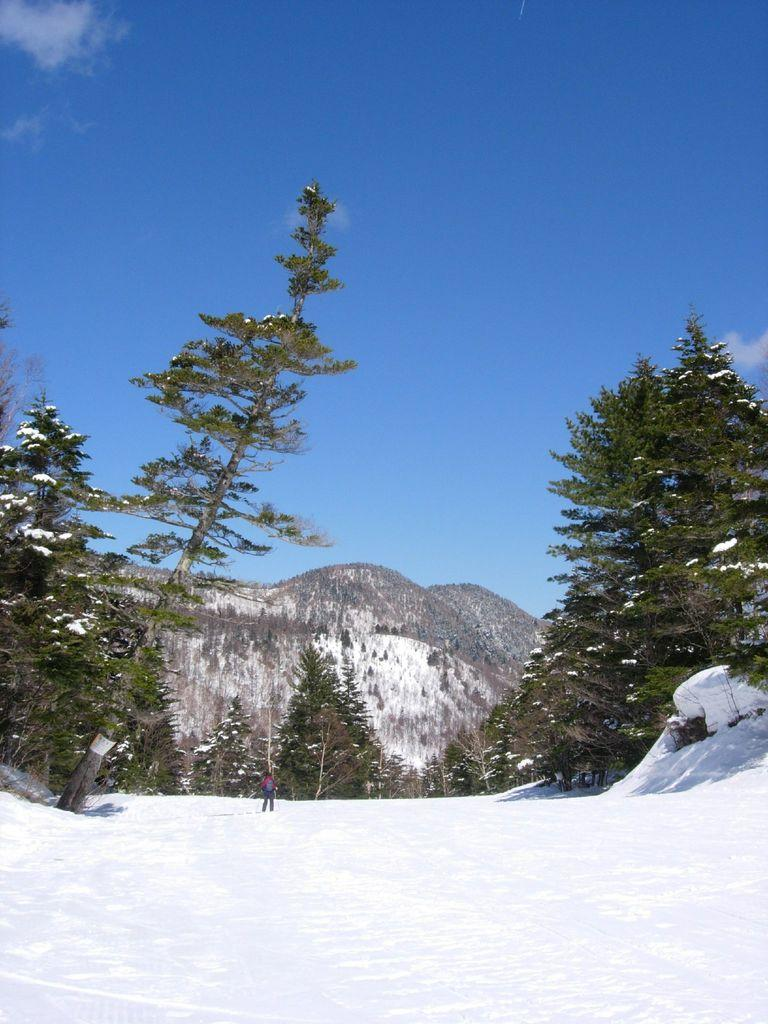What can be seen in the background of the image? There is a clear blue sky, hills, and trees visible in the background of the image. What is the weather like in the image? The clear blue sky suggests good weather. Can you describe the person in the image? There is a person standing in the image. What is the terrain like in the image? The presence of hills and snow at the bottom portion of the image suggests a hilly, snowy terrain. What type of hose is being used by the person in the image? There is no hose present in the image. Can you tell me the color of the sock the person is wearing in the image? There is no sock visible in the image. 